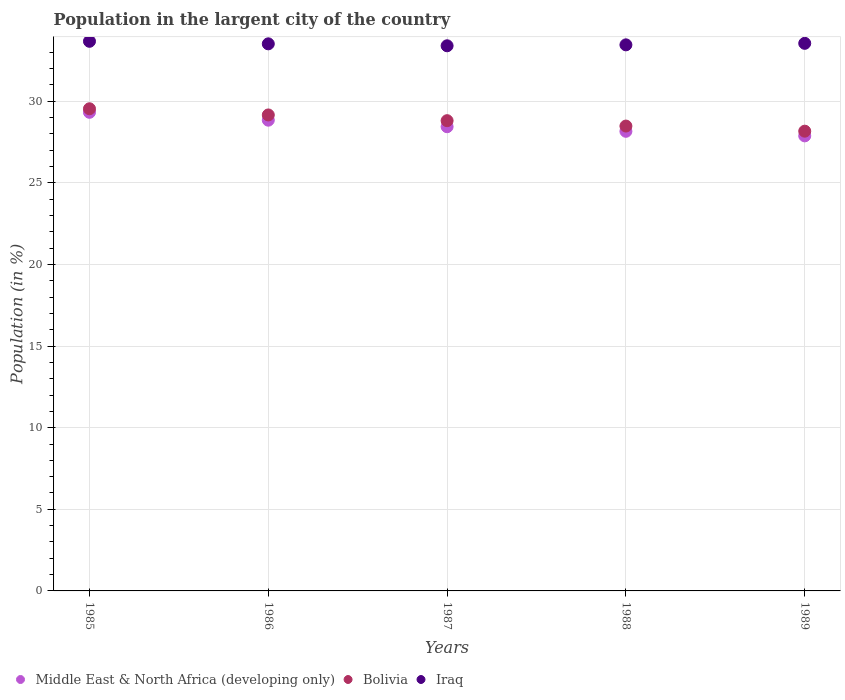How many different coloured dotlines are there?
Your answer should be very brief. 3. What is the percentage of population in the largent city in Middle East & North Africa (developing only) in 1988?
Your answer should be compact. 28.16. Across all years, what is the maximum percentage of population in the largent city in Bolivia?
Offer a very short reply. 29.54. Across all years, what is the minimum percentage of population in the largent city in Bolivia?
Your response must be concise. 28.17. In which year was the percentage of population in the largent city in Iraq maximum?
Make the answer very short. 1985. What is the total percentage of population in the largent city in Iraq in the graph?
Your response must be concise. 167.59. What is the difference between the percentage of population in the largent city in Middle East & North Africa (developing only) in 1985 and that in 1987?
Keep it short and to the point. 0.88. What is the difference between the percentage of population in the largent city in Bolivia in 1985 and the percentage of population in the largent city in Iraq in 1986?
Provide a succinct answer. -3.98. What is the average percentage of population in the largent city in Middle East & North Africa (developing only) per year?
Your answer should be compact. 28.53. In the year 1985, what is the difference between the percentage of population in the largent city in Iraq and percentage of population in the largent city in Bolivia?
Offer a very short reply. 4.13. What is the ratio of the percentage of population in the largent city in Bolivia in 1985 to that in 1987?
Your answer should be very brief. 1.03. Is the percentage of population in the largent city in Iraq in 1985 less than that in 1988?
Ensure brevity in your answer.  No. What is the difference between the highest and the second highest percentage of population in the largent city in Bolivia?
Provide a succinct answer. 0.38. What is the difference between the highest and the lowest percentage of population in the largent city in Middle East & North Africa (developing only)?
Make the answer very short. 1.44. In how many years, is the percentage of population in the largent city in Bolivia greater than the average percentage of population in the largent city in Bolivia taken over all years?
Keep it short and to the point. 2. Is it the case that in every year, the sum of the percentage of population in the largent city in Iraq and percentage of population in the largent city in Middle East & North Africa (developing only)  is greater than the percentage of population in the largent city in Bolivia?
Your answer should be very brief. Yes. Does the percentage of population in the largent city in Iraq monotonically increase over the years?
Make the answer very short. No. Is the percentage of population in the largent city in Bolivia strictly greater than the percentage of population in the largent city in Middle East & North Africa (developing only) over the years?
Your response must be concise. Yes. What is the difference between two consecutive major ticks on the Y-axis?
Give a very brief answer. 5. Does the graph contain any zero values?
Make the answer very short. No. Does the graph contain grids?
Offer a terse response. Yes. What is the title of the graph?
Offer a terse response. Population in the largent city of the country. Does "Seychelles" appear as one of the legend labels in the graph?
Give a very brief answer. No. What is the label or title of the Y-axis?
Make the answer very short. Population (in %). What is the Population (in %) in Middle East & North Africa (developing only) in 1985?
Keep it short and to the point. 29.32. What is the Population (in %) of Bolivia in 1985?
Provide a short and direct response. 29.54. What is the Population (in %) in Iraq in 1985?
Offer a very short reply. 33.67. What is the Population (in %) in Middle East & North Africa (developing only) in 1986?
Your answer should be compact. 28.84. What is the Population (in %) in Bolivia in 1986?
Offer a very short reply. 29.16. What is the Population (in %) in Iraq in 1986?
Your answer should be very brief. 33.52. What is the Population (in %) of Middle East & North Africa (developing only) in 1987?
Offer a very short reply. 28.44. What is the Population (in %) in Bolivia in 1987?
Make the answer very short. 28.81. What is the Population (in %) of Iraq in 1987?
Offer a terse response. 33.4. What is the Population (in %) in Middle East & North Africa (developing only) in 1988?
Keep it short and to the point. 28.16. What is the Population (in %) in Bolivia in 1988?
Provide a succinct answer. 28.48. What is the Population (in %) in Iraq in 1988?
Offer a very short reply. 33.46. What is the Population (in %) of Middle East & North Africa (developing only) in 1989?
Offer a terse response. 27.88. What is the Population (in %) in Bolivia in 1989?
Offer a terse response. 28.17. What is the Population (in %) in Iraq in 1989?
Give a very brief answer. 33.55. Across all years, what is the maximum Population (in %) in Middle East & North Africa (developing only)?
Provide a short and direct response. 29.32. Across all years, what is the maximum Population (in %) of Bolivia?
Provide a short and direct response. 29.54. Across all years, what is the maximum Population (in %) of Iraq?
Ensure brevity in your answer.  33.67. Across all years, what is the minimum Population (in %) in Middle East & North Africa (developing only)?
Ensure brevity in your answer.  27.88. Across all years, what is the minimum Population (in %) of Bolivia?
Your answer should be compact. 28.17. Across all years, what is the minimum Population (in %) in Iraq?
Provide a short and direct response. 33.4. What is the total Population (in %) in Middle East & North Africa (developing only) in the graph?
Your answer should be compact. 142.64. What is the total Population (in %) of Bolivia in the graph?
Your response must be concise. 144.16. What is the total Population (in %) in Iraq in the graph?
Ensure brevity in your answer.  167.59. What is the difference between the Population (in %) in Middle East & North Africa (developing only) in 1985 and that in 1986?
Offer a terse response. 0.48. What is the difference between the Population (in %) of Bolivia in 1985 and that in 1986?
Keep it short and to the point. 0.38. What is the difference between the Population (in %) of Iraq in 1985 and that in 1986?
Provide a short and direct response. 0.16. What is the difference between the Population (in %) in Middle East & North Africa (developing only) in 1985 and that in 1987?
Ensure brevity in your answer.  0.88. What is the difference between the Population (in %) in Bolivia in 1985 and that in 1987?
Make the answer very short. 0.73. What is the difference between the Population (in %) in Iraq in 1985 and that in 1987?
Make the answer very short. 0.27. What is the difference between the Population (in %) of Middle East & North Africa (developing only) in 1985 and that in 1988?
Provide a succinct answer. 1.16. What is the difference between the Population (in %) of Bolivia in 1985 and that in 1988?
Provide a succinct answer. 1.06. What is the difference between the Population (in %) in Iraq in 1985 and that in 1988?
Make the answer very short. 0.22. What is the difference between the Population (in %) in Middle East & North Africa (developing only) in 1985 and that in 1989?
Offer a very short reply. 1.44. What is the difference between the Population (in %) in Bolivia in 1985 and that in 1989?
Provide a succinct answer. 1.37. What is the difference between the Population (in %) of Iraq in 1985 and that in 1989?
Provide a short and direct response. 0.12. What is the difference between the Population (in %) in Middle East & North Africa (developing only) in 1986 and that in 1987?
Ensure brevity in your answer.  0.4. What is the difference between the Population (in %) of Bolivia in 1986 and that in 1987?
Offer a terse response. 0.35. What is the difference between the Population (in %) of Iraq in 1986 and that in 1987?
Give a very brief answer. 0.12. What is the difference between the Population (in %) in Middle East & North Africa (developing only) in 1986 and that in 1988?
Your answer should be compact. 0.68. What is the difference between the Population (in %) in Bolivia in 1986 and that in 1988?
Provide a succinct answer. 0.68. What is the difference between the Population (in %) in Iraq in 1986 and that in 1988?
Give a very brief answer. 0.06. What is the difference between the Population (in %) of Middle East & North Africa (developing only) in 1986 and that in 1989?
Provide a short and direct response. 0.96. What is the difference between the Population (in %) in Iraq in 1986 and that in 1989?
Offer a terse response. -0.03. What is the difference between the Population (in %) in Middle East & North Africa (developing only) in 1987 and that in 1988?
Give a very brief answer. 0.28. What is the difference between the Population (in %) of Bolivia in 1987 and that in 1988?
Provide a short and direct response. 0.33. What is the difference between the Population (in %) in Iraq in 1987 and that in 1988?
Offer a terse response. -0.06. What is the difference between the Population (in %) in Middle East & North Africa (developing only) in 1987 and that in 1989?
Provide a short and direct response. 0.56. What is the difference between the Population (in %) of Bolivia in 1987 and that in 1989?
Offer a very short reply. 0.64. What is the difference between the Population (in %) in Iraq in 1987 and that in 1989?
Keep it short and to the point. -0.15. What is the difference between the Population (in %) in Middle East & North Africa (developing only) in 1988 and that in 1989?
Your answer should be compact. 0.28. What is the difference between the Population (in %) of Bolivia in 1988 and that in 1989?
Give a very brief answer. 0.31. What is the difference between the Population (in %) in Iraq in 1988 and that in 1989?
Give a very brief answer. -0.09. What is the difference between the Population (in %) in Middle East & North Africa (developing only) in 1985 and the Population (in %) in Bolivia in 1986?
Provide a short and direct response. 0.16. What is the difference between the Population (in %) in Middle East & North Africa (developing only) in 1985 and the Population (in %) in Iraq in 1986?
Offer a terse response. -4.19. What is the difference between the Population (in %) of Bolivia in 1985 and the Population (in %) of Iraq in 1986?
Make the answer very short. -3.98. What is the difference between the Population (in %) of Middle East & North Africa (developing only) in 1985 and the Population (in %) of Bolivia in 1987?
Ensure brevity in your answer.  0.51. What is the difference between the Population (in %) of Middle East & North Africa (developing only) in 1985 and the Population (in %) of Iraq in 1987?
Your answer should be compact. -4.08. What is the difference between the Population (in %) in Bolivia in 1985 and the Population (in %) in Iraq in 1987?
Provide a short and direct response. -3.86. What is the difference between the Population (in %) in Middle East & North Africa (developing only) in 1985 and the Population (in %) in Bolivia in 1988?
Provide a succinct answer. 0.84. What is the difference between the Population (in %) of Middle East & North Africa (developing only) in 1985 and the Population (in %) of Iraq in 1988?
Ensure brevity in your answer.  -4.13. What is the difference between the Population (in %) of Bolivia in 1985 and the Population (in %) of Iraq in 1988?
Provide a succinct answer. -3.92. What is the difference between the Population (in %) of Middle East & North Africa (developing only) in 1985 and the Population (in %) of Bolivia in 1989?
Offer a terse response. 1.16. What is the difference between the Population (in %) in Middle East & North Africa (developing only) in 1985 and the Population (in %) in Iraq in 1989?
Your response must be concise. -4.23. What is the difference between the Population (in %) in Bolivia in 1985 and the Population (in %) in Iraq in 1989?
Provide a short and direct response. -4.01. What is the difference between the Population (in %) in Middle East & North Africa (developing only) in 1986 and the Population (in %) in Bolivia in 1987?
Your answer should be very brief. 0.03. What is the difference between the Population (in %) of Middle East & North Africa (developing only) in 1986 and the Population (in %) of Iraq in 1987?
Ensure brevity in your answer.  -4.56. What is the difference between the Population (in %) of Bolivia in 1986 and the Population (in %) of Iraq in 1987?
Ensure brevity in your answer.  -4.24. What is the difference between the Population (in %) in Middle East & North Africa (developing only) in 1986 and the Population (in %) in Bolivia in 1988?
Your answer should be compact. 0.36. What is the difference between the Population (in %) in Middle East & North Africa (developing only) in 1986 and the Population (in %) in Iraq in 1988?
Your answer should be compact. -4.62. What is the difference between the Population (in %) of Bolivia in 1986 and the Population (in %) of Iraq in 1988?
Give a very brief answer. -4.29. What is the difference between the Population (in %) of Middle East & North Africa (developing only) in 1986 and the Population (in %) of Bolivia in 1989?
Give a very brief answer. 0.67. What is the difference between the Population (in %) of Middle East & North Africa (developing only) in 1986 and the Population (in %) of Iraq in 1989?
Ensure brevity in your answer.  -4.71. What is the difference between the Population (in %) of Bolivia in 1986 and the Population (in %) of Iraq in 1989?
Ensure brevity in your answer.  -4.39. What is the difference between the Population (in %) in Middle East & North Africa (developing only) in 1987 and the Population (in %) in Bolivia in 1988?
Keep it short and to the point. -0.04. What is the difference between the Population (in %) in Middle East & North Africa (developing only) in 1987 and the Population (in %) in Iraq in 1988?
Give a very brief answer. -5.02. What is the difference between the Population (in %) in Bolivia in 1987 and the Population (in %) in Iraq in 1988?
Ensure brevity in your answer.  -4.65. What is the difference between the Population (in %) in Middle East & North Africa (developing only) in 1987 and the Population (in %) in Bolivia in 1989?
Your answer should be compact. 0.27. What is the difference between the Population (in %) of Middle East & North Africa (developing only) in 1987 and the Population (in %) of Iraq in 1989?
Give a very brief answer. -5.11. What is the difference between the Population (in %) in Bolivia in 1987 and the Population (in %) in Iraq in 1989?
Your response must be concise. -4.74. What is the difference between the Population (in %) in Middle East & North Africa (developing only) in 1988 and the Population (in %) in Bolivia in 1989?
Provide a short and direct response. -0.01. What is the difference between the Population (in %) in Middle East & North Africa (developing only) in 1988 and the Population (in %) in Iraq in 1989?
Offer a terse response. -5.39. What is the difference between the Population (in %) in Bolivia in 1988 and the Population (in %) in Iraq in 1989?
Your answer should be compact. -5.07. What is the average Population (in %) of Middle East & North Africa (developing only) per year?
Your response must be concise. 28.53. What is the average Population (in %) of Bolivia per year?
Keep it short and to the point. 28.83. What is the average Population (in %) of Iraq per year?
Offer a terse response. 33.52. In the year 1985, what is the difference between the Population (in %) in Middle East & North Africa (developing only) and Population (in %) in Bolivia?
Ensure brevity in your answer.  -0.22. In the year 1985, what is the difference between the Population (in %) of Middle East & North Africa (developing only) and Population (in %) of Iraq?
Provide a succinct answer. -4.35. In the year 1985, what is the difference between the Population (in %) in Bolivia and Population (in %) in Iraq?
Offer a terse response. -4.13. In the year 1986, what is the difference between the Population (in %) of Middle East & North Africa (developing only) and Population (in %) of Bolivia?
Provide a succinct answer. -0.32. In the year 1986, what is the difference between the Population (in %) in Middle East & North Africa (developing only) and Population (in %) in Iraq?
Make the answer very short. -4.68. In the year 1986, what is the difference between the Population (in %) of Bolivia and Population (in %) of Iraq?
Your answer should be compact. -4.36. In the year 1987, what is the difference between the Population (in %) in Middle East & North Africa (developing only) and Population (in %) in Bolivia?
Offer a terse response. -0.37. In the year 1987, what is the difference between the Population (in %) of Middle East & North Africa (developing only) and Population (in %) of Iraq?
Offer a terse response. -4.96. In the year 1987, what is the difference between the Population (in %) in Bolivia and Population (in %) in Iraq?
Your answer should be compact. -4.59. In the year 1988, what is the difference between the Population (in %) in Middle East & North Africa (developing only) and Population (in %) in Bolivia?
Offer a very short reply. -0.32. In the year 1988, what is the difference between the Population (in %) in Middle East & North Africa (developing only) and Population (in %) in Iraq?
Give a very brief answer. -5.3. In the year 1988, what is the difference between the Population (in %) in Bolivia and Population (in %) in Iraq?
Ensure brevity in your answer.  -4.98. In the year 1989, what is the difference between the Population (in %) of Middle East & North Africa (developing only) and Population (in %) of Bolivia?
Provide a short and direct response. -0.29. In the year 1989, what is the difference between the Population (in %) in Middle East & North Africa (developing only) and Population (in %) in Iraq?
Ensure brevity in your answer.  -5.67. In the year 1989, what is the difference between the Population (in %) in Bolivia and Population (in %) in Iraq?
Ensure brevity in your answer.  -5.38. What is the ratio of the Population (in %) of Middle East & North Africa (developing only) in 1985 to that in 1986?
Offer a terse response. 1.02. What is the ratio of the Population (in %) in Bolivia in 1985 to that in 1986?
Offer a very short reply. 1.01. What is the ratio of the Population (in %) of Iraq in 1985 to that in 1986?
Your answer should be very brief. 1. What is the ratio of the Population (in %) of Middle East & North Africa (developing only) in 1985 to that in 1987?
Ensure brevity in your answer.  1.03. What is the ratio of the Population (in %) in Bolivia in 1985 to that in 1987?
Ensure brevity in your answer.  1.03. What is the ratio of the Population (in %) of Iraq in 1985 to that in 1987?
Ensure brevity in your answer.  1.01. What is the ratio of the Population (in %) of Middle East & North Africa (developing only) in 1985 to that in 1988?
Provide a short and direct response. 1.04. What is the ratio of the Population (in %) in Bolivia in 1985 to that in 1988?
Offer a very short reply. 1.04. What is the ratio of the Population (in %) of Iraq in 1985 to that in 1988?
Keep it short and to the point. 1.01. What is the ratio of the Population (in %) in Middle East & North Africa (developing only) in 1985 to that in 1989?
Offer a very short reply. 1.05. What is the ratio of the Population (in %) of Bolivia in 1985 to that in 1989?
Provide a short and direct response. 1.05. What is the ratio of the Population (in %) of Iraq in 1985 to that in 1989?
Offer a terse response. 1. What is the ratio of the Population (in %) in Middle East & North Africa (developing only) in 1986 to that in 1987?
Provide a succinct answer. 1.01. What is the ratio of the Population (in %) of Bolivia in 1986 to that in 1987?
Keep it short and to the point. 1.01. What is the ratio of the Population (in %) of Middle East & North Africa (developing only) in 1986 to that in 1988?
Ensure brevity in your answer.  1.02. What is the ratio of the Population (in %) in Bolivia in 1986 to that in 1988?
Offer a very short reply. 1.02. What is the ratio of the Population (in %) in Middle East & North Africa (developing only) in 1986 to that in 1989?
Make the answer very short. 1.03. What is the ratio of the Population (in %) in Bolivia in 1986 to that in 1989?
Provide a succinct answer. 1.04. What is the ratio of the Population (in %) of Bolivia in 1987 to that in 1988?
Your response must be concise. 1.01. What is the ratio of the Population (in %) in Iraq in 1987 to that in 1988?
Your answer should be compact. 1. What is the ratio of the Population (in %) of Middle East & North Africa (developing only) in 1987 to that in 1989?
Keep it short and to the point. 1.02. What is the ratio of the Population (in %) of Bolivia in 1987 to that in 1989?
Your answer should be compact. 1.02. What is the ratio of the Population (in %) of Iraq in 1987 to that in 1989?
Provide a short and direct response. 1. What is the ratio of the Population (in %) in Middle East & North Africa (developing only) in 1988 to that in 1989?
Keep it short and to the point. 1.01. What is the ratio of the Population (in %) in Bolivia in 1988 to that in 1989?
Offer a terse response. 1.01. What is the difference between the highest and the second highest Population (in %) in Middle East & North Africa (developing only)?
Offer a terse response. 0.48. What is the difference between the highest and the second highest Population (in %) in Bolivia?
Provide a short and direct response. 0.38. What is the difference between the highest and the second highest Population (in %) in Iraq?
Your answer should be very brief. 0.12. What is the difference between the highest and the lowest Population (in %) of Middle East & North Africa (developing only)?
Provide a succinct answer. 1.44. What is the difference between the highest and the lowest Population (in %) in Bolivia?
Keep it short and to the point. 1.37. What is the difference between the highest and the lowest Population (in %) in Iraq?
Ensure brevity in your answer.  0.27. 